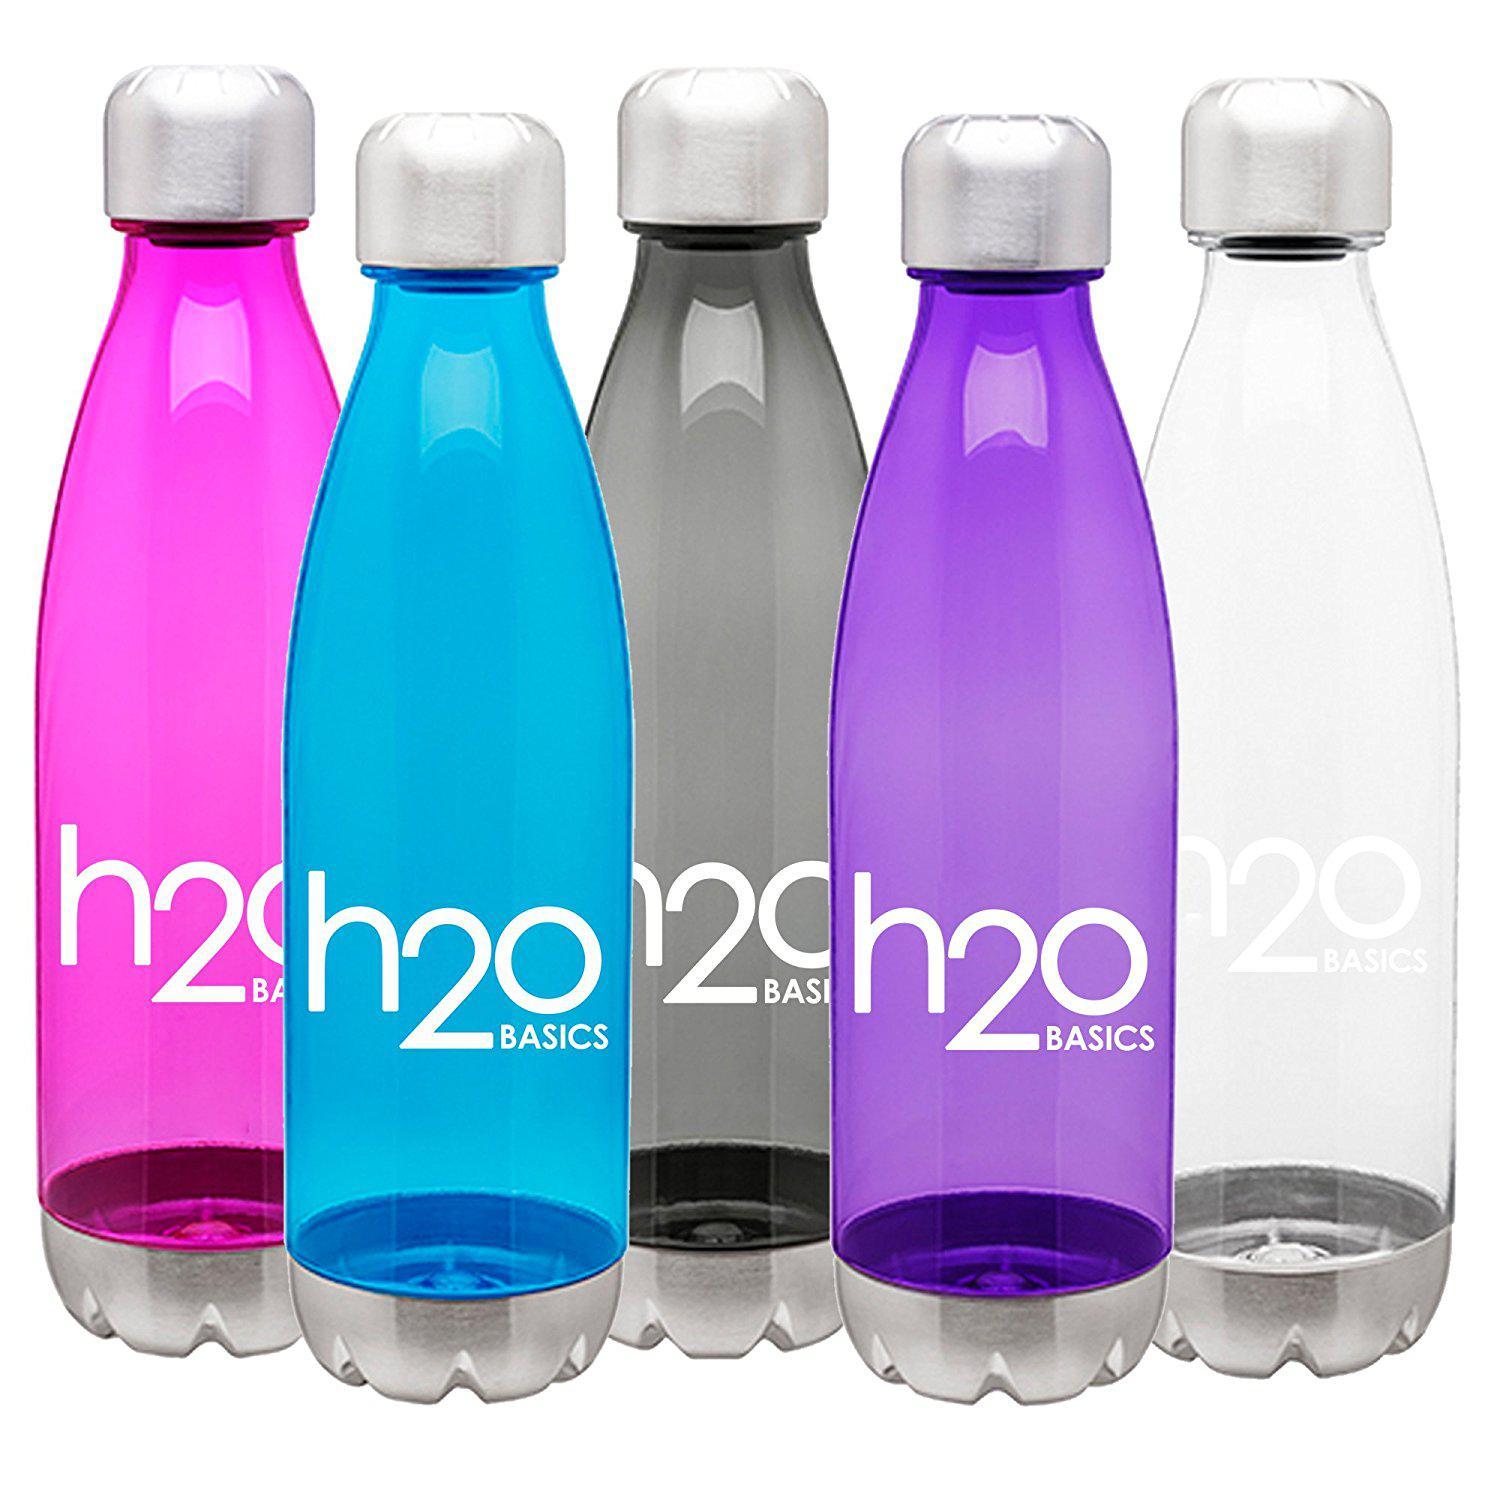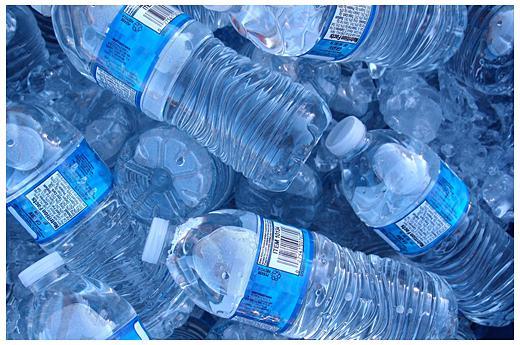The first image is the image on the left, the second image is the image on the right. For the images shown, is this caption "There are exactly four bottles of water in one of the images." true? Answer yes or no. No. 